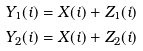<formula> <loc_0><loc_0><loc_500><loc_500>Y _ { 1 } ( i ) & = X ( i ) + Z _ { 1 } ( i ) \\ Y _ { 2 } ( i ) & = X ( i ) + Z _ { 2 } ( i )</formula> 